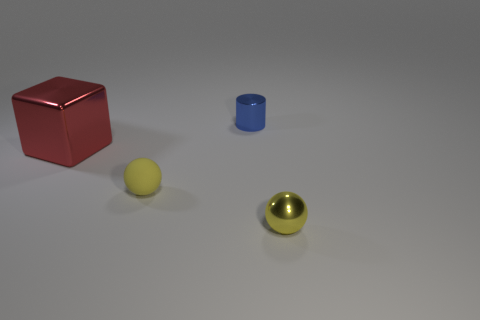Add 1 tiny things. How many objects exist? 5 Subtract all blocks. How many objects are left? 3 Add 1 small blue cylinders. How many small blue cylinders exist? 2 Subtract 0 blue cubes. How many objects are left? 4 Subtract all large red objects. Subtract all red balls. How many objects are left? 3 Add 3 small shiny cylinders. How many small shiny cylinders are left? 4 